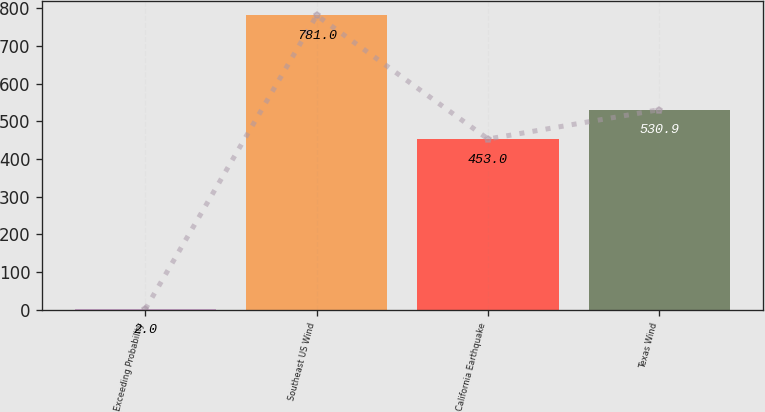Convert chart to OTSL. <chart><loc_0><loc_0><loc_500><loc_500><bar_chart><fcel>Exceeding Probability<fcel>Southeast US Wind<fcel>California Earthquake<fcel>Texas Wind<nl><fcel>2<fcel>781<fcel>453<fcel>530.9<nl></chart> 